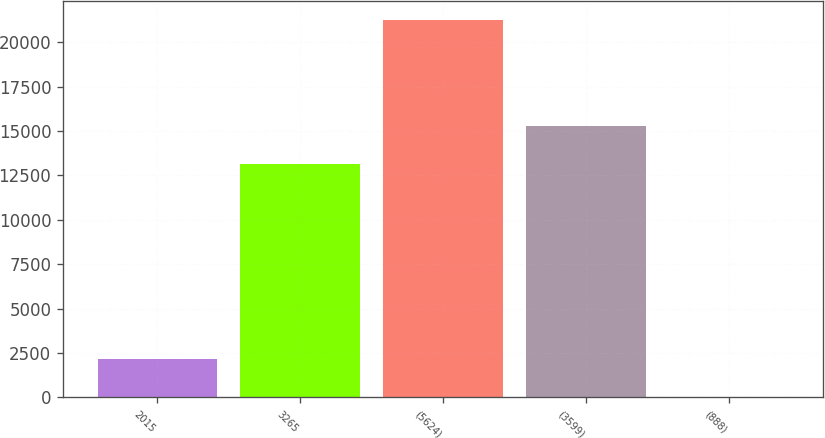<chart> <loc_0><loc_0><loc_500><loc_500><bar_chart><fcel>2015<fcel>3265<fcel>(5624)<fcel>(3599)<fcel>(888)<nl><fcel>2158.8<fcel>13145<fcel>21268<fcel>15268.2<fcel>35.55<nl></chart> 